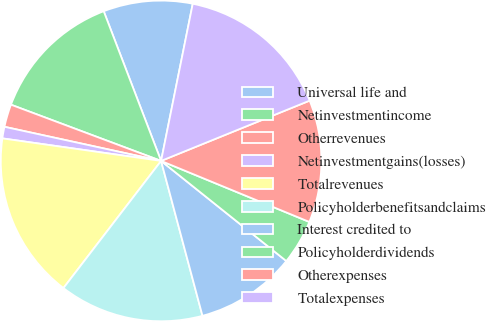<chart> <loc_0><loc_0><loc_500><loc_500><pie_chart><fcel>Universal life and<fcel>Netinvestmentincome<fcel>Otherrevenues<fcel>Netinvestmentgains(losses)<fcel>Totalrevenues<fcel>Policyholderbenefitsandclaims<fcel>Interest credited to<fcel>Policyholderdividends<fcel>Otherexpenses<fcel>Totalexpenses<nl><fcel>8.99%<fcel>13.47%<fcel>2.29%<fcel>1.17%<fcel>16.82%<fcel>14.58%<fcel>10.11%<fcel>4.52%<fcel>12.35%<fcel>15.7%<nl></chart> 